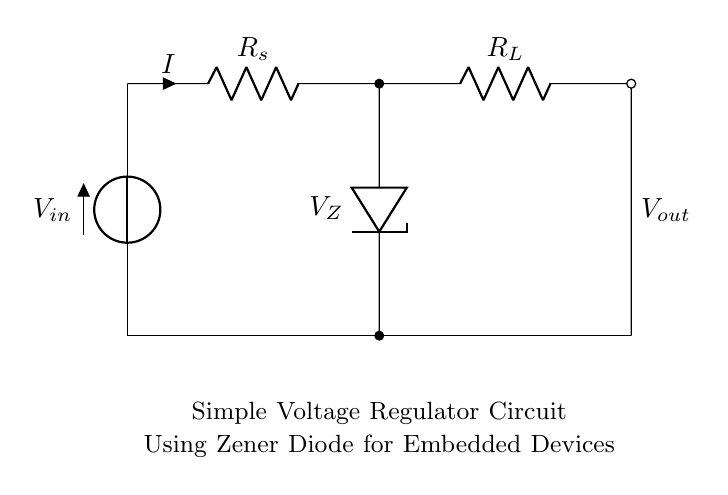What type of diode is used in this circuit? The circuit uses a Zener diode, which is indicated by the symbol labeled with 'zD'. Zener diodes are specifically designed to allow current to flow in the reverse direction when a specified reverse voltage is achieved, functioning as voltage regulators.
Answer: Zener diode What is the purpose of the resistor R_s? The series resistor R_s limits the current flowing into the Zener diode and the load resistor. By controlling the amount of current, it helps to prevent damage to the Zener diode and ensures stable operation by maintaining a proper voltage across the load under varying load conditions.
Answer: Current limiter What is the expected output voltage V_out from this circuit? The output voltage V_out is stabilized by the Zener diode and is equal to the Zener voltage V_Z when the diode is in breakdown. Thus, the output voltage is determined by the selected Zener diode. This information may need to be specified outside of the circuit itself (the diagram does not state it directly).
Answer: Equal to V_Z How does the Zener diode stabilize the output voltage? The Zener diode stabilizes the output voltage by allowing current to flow in reverse once the voltage across it exceeds its Zener voltage. This maintains a constant voltage across the load resistor R_L despite variations in the input voltage or load current, effectively clamping the voltage to a predetermined value defined by the Zener diode's characteristics.
Answer: By reverse breakdown What happens if the input voltage V_in exceeds a certain limit? If the input voltage V_in exceeds the maximum rating of the Zener diode, it may lead to excessive current flowing through the diode which could cause it to overheat and potentially fail. This can result in a loss of regulation or damage to the diode and the connected load. Hence, it’s critical to keep the input voltage within specified limits.
Answer: Overheating and damage What is the function of the load resistor R_L? The load resistor R_L serves as the component that draws current from the regulated output voltage V_out. It represents the device or circuit that requires the stable voltage provided by the Zener regulator. The value of R_L affects the load current and, consequently, the power dissipation in the circuit.
Answer: Load connection What is the significance of the ground connections in this circuit? The ground connections in this circuit serve as the reference point for all voltages in the circuit. They establish a common return path for the electric current and provide a stable voltage reference for the load resistor and Zener diode, ensuring proper functioning of the voltage regulation.
Answer: Common reference 